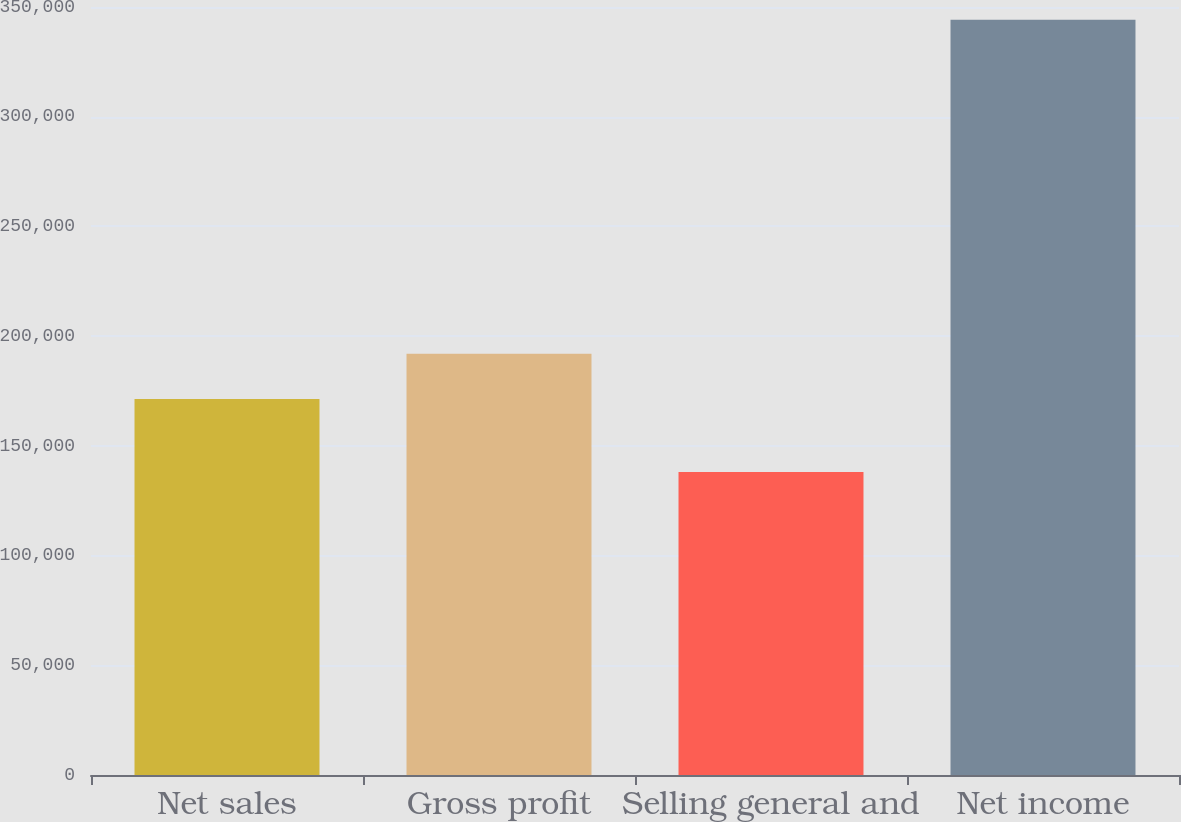<chart> <loc_0><loc_0><loc_500><loc_500><bar_chart><fcel>Net sales<fcel>Gross profit<fcel>Selling general and<fcel>Net income<nl><fcel>171369<fcel>191977<fcel>138111<fcel>344190<nl></chart> 